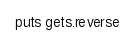Convert code to text. <code><loc_0><loc_0><loc_500><loc_500><_Ruby_>puts gets.reverse</code> 